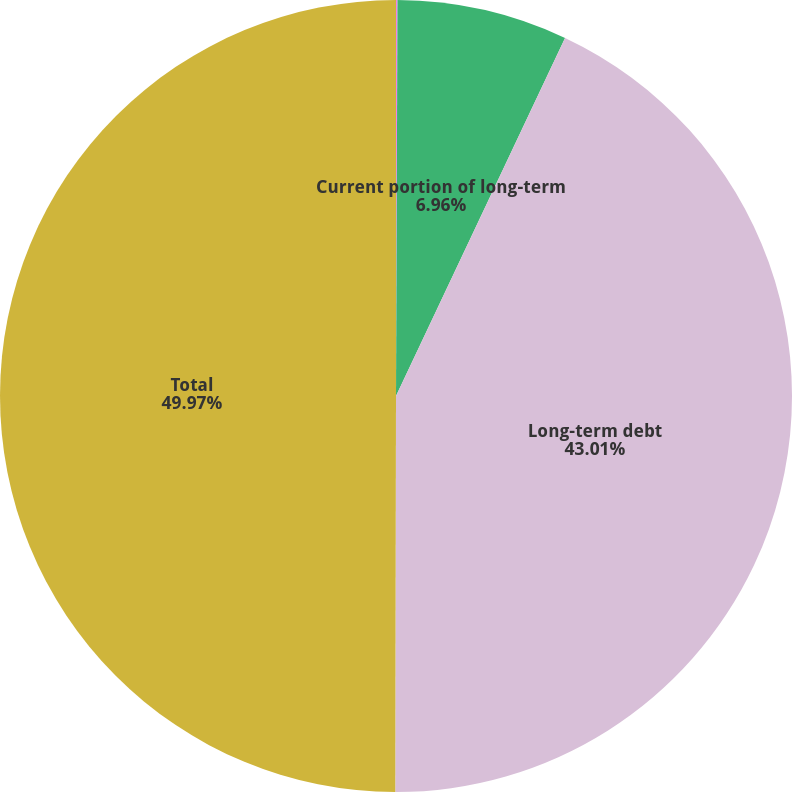Convert chart to OTSL. <chart><loc_0><loc_0><loc_500><loc_500><pie_chart><fcel>At December 31<fcel>Current portion of long-term<fcel>Long-term debt<fcel>Total<nl><fcel>0.06%<fcel>6.96%<fcel>43.01%<fcel>49.97%<nl></chart> 